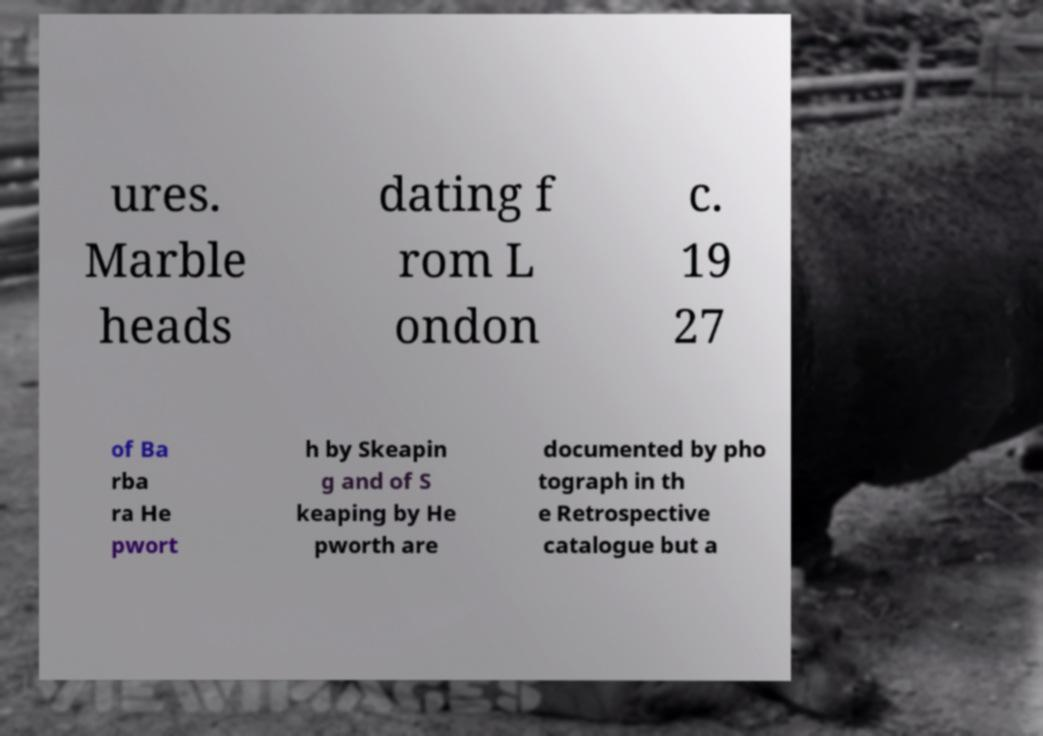Can you accurately transcribe the text from the provided image for me? ures. Marble heads dating f rom L ondon c. 19 27 of Ba rba ra He pwort h by Skeapin g and of S keaping by He pworth are documented by pho tograph in th e Retrospective catalogue but a 